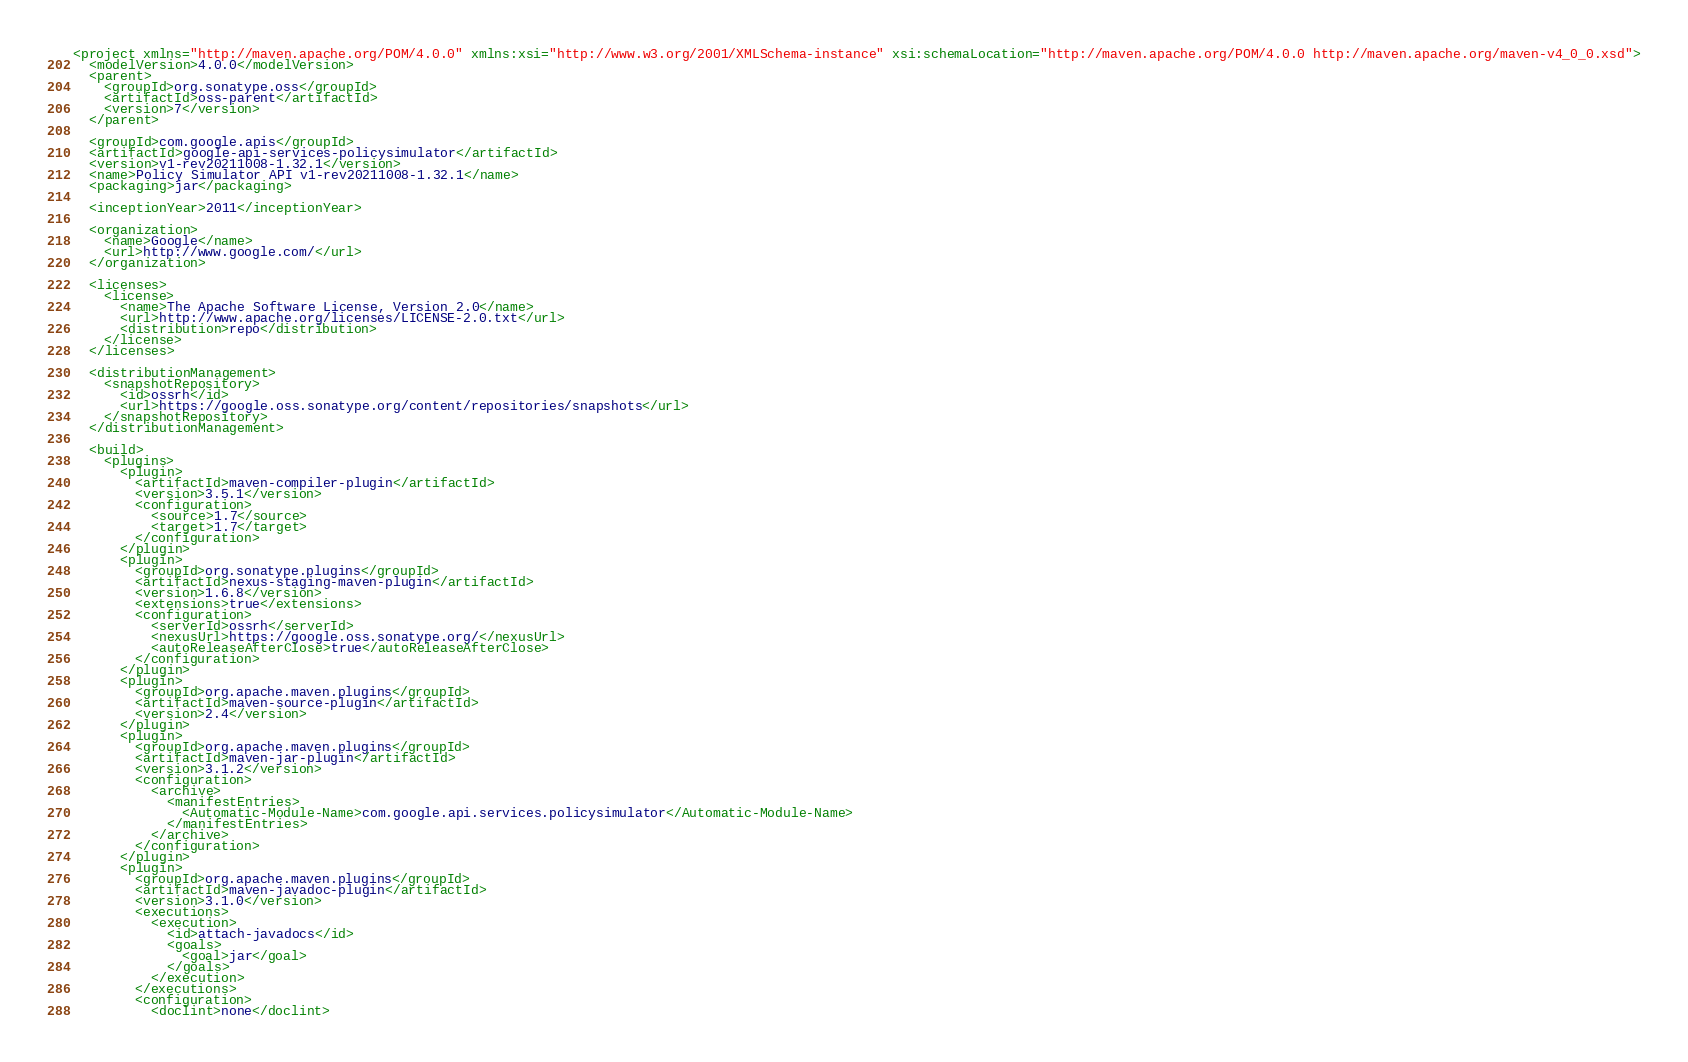Convert code to text. <code><loc_0><loc_0><loc_500><loc_500><_XML_><project xmlns="http://maven.apache.org/POM/4.0.0" xmlns:xsi="http://www.w3.org/2001/XMLSchema-instance" xsi:schemaLocation="http://maven.apache.org/POM/4.0.0 http://maven.apache.org/maven-v4_0_0.xsd">
  <modelVersion>4.0.0</modelVersion>
  <parent>
    <groupId>org.sonatype.oss</groupId>
    <artifactId>oss-parent</artifactId>
    <version>7</version>
  </parent>

  <groupId>com.google.apis</groupId>
  <artifactId>google-api-services-policysimulator</artifactId>
  <version>v1-rev20211008-1.32.1</version>
  <name>Policy Simulator API v1-rev20211008-1.32.1</name>
  <packaging>jar</packaging>

  <inceptionYear>2011</inceptionYear>

  <organization>
    <name>Google</name>
    <url>http://www.google.com/</url>
  </organization>

  <licenses>
    <license>
      <name>The Apache Software License, Version 2.0</name>
      <url>http://www.apache.org/licenses/LICENSE-2.0.txt</url>
      <distribution>repo</distribution>
    </license>
  </licenses>

  <distributionManagement>
    <snapshotRepository>
      <id>ossrh</id>
      <url>https://google.oss.sonatype.org/content/repositories/snapshots</url>
    </snapshotRepository>
  </distributionManagement>

  <build>
    <plugins>
      <plugin>
        <artifactId>maven-compiler-plugin</artifactId>
        <version>3.5.1</version>
        <configuration>
          <source>1.7</source>
          <target>1.7</target>
        </configuration>
      </plugin>
      <plugin>
        <groupId>org.sonatype.plugins</groupId>
        <artifactId>nexus-staging-maven-plugin</artifactId>
        <version>1.6.8</version>
        <extensions>true</extensions>
        <configuration>
          <serverId>ossrh</serverId>
          <nexusUrl>https://google.oss.sonatype.org/</nexusUrl>
          <autoReleaseAfterClose>true</autoReleaseAfterClose>
        </configuration>
      </plugin>
      <plugin>
        <groupId>org.apache.maven.plugins</groupId>
        <artifactId>maven-source-plugin</artifactId>
        <version>2.4</version>
      </plugin>
      <plugin>
        <groupId>org.apache.maven.plugins</groupId>
        <artifactId>maven-jar-plugin</artifactId>
        <version>3.1.2</version>
        <configuration>
          <archive>
            <manifestEntries>
              <Automatic-Module-Name>com.google.api.services.policysimulator</Automatic-Module-Name>
            </manifestEntries>
          </archive>
        </configuration>
      </plugin>
      <plugin>
        <groupId>org.apache.maven.plugins</groupId>
        <artifactId>maven-javadoc-plugin</artifactId>
        <version>3.1.0</version>
        <executions>
          <execution>
            <id>attach-javadocs</id>
            <goals>
              <goal>jar</goal>
            </goals>
          </execution>
        </executions>
        <configuration>
          <doclint>none</doclint></code> 